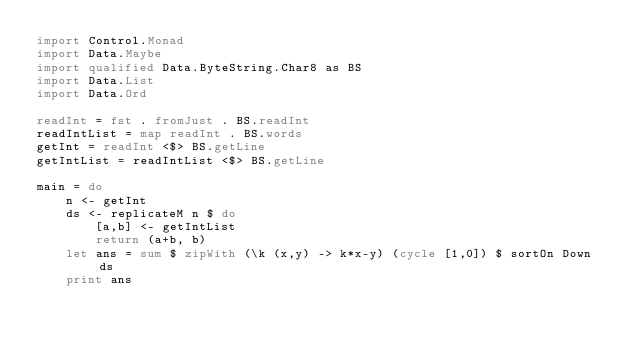Convert code to text. <code><loc_0><loc_0><loc_500><loc_500><_Haskell_>import Control.Monad
import Data.Maybe
import qualified Data.ByteString.Char8 as BS
import Data.List
import Data.Ord

readInt = fst . fromJust . BS.readInt
readIntList = map readInt . BS.words
getInt = readInt <$> BS.getLine
getIntList = readIntList <$> BS.getLine

main = do
    n <- getInt
    ds <- replicateM n $ do
        [a,b] <- getIntList
        return (a+b, b)
    let ans = sum $ zipWith (\k (x,y) -> k*x-y) (cycle [1,0]) $ sortOn Down ds
    print ans</code> 